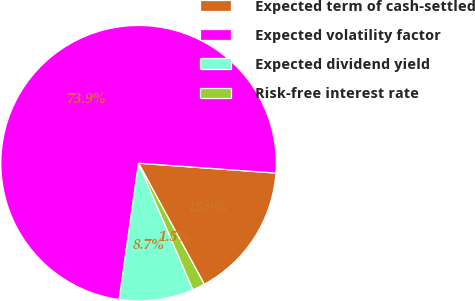<chart> <loc_0><loc_0><loc_500><loc_500><pie_chart><fcel>Expected term of cash-settled<fcel>Expected volatility factor<fcel>Expected dividend yield<fcel>Risk-free interest rate<nl><fcel>15.94%<fcel>73.9%<fcel>8.7%<fcel>1.46%<nl></chart> 